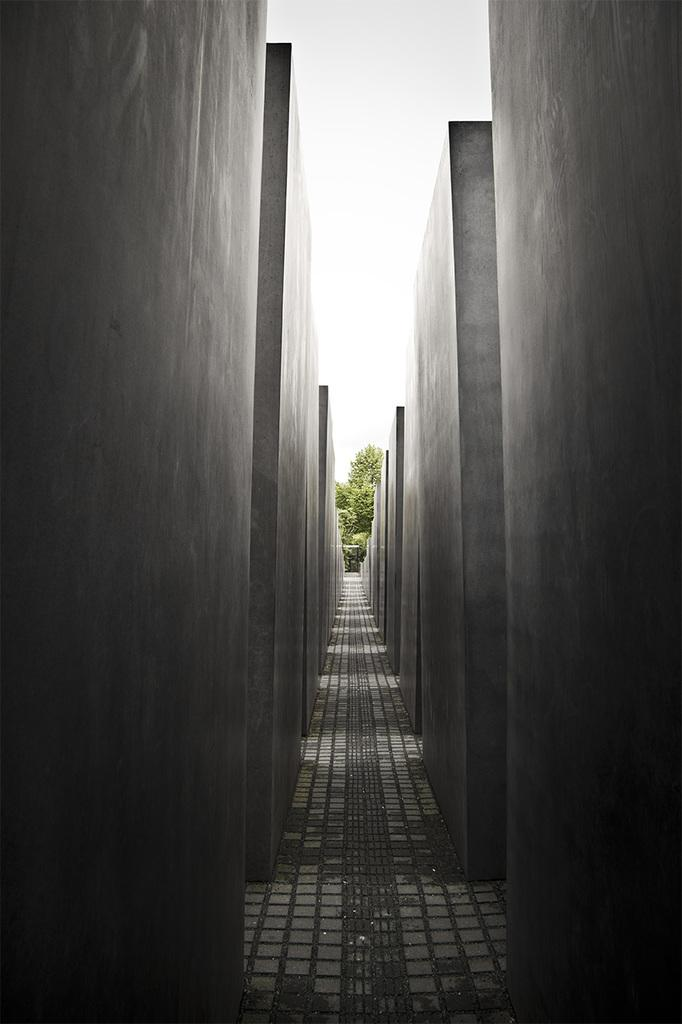What is present on both sides of the image? There are walls on both sides of the image. What is at the bottom of the image? There is pavement at the bottom of the image. What can be seen in the background of the image? There is sky and trees visible in the background of the image. Can you see any celery growing in the image? There is no celery present in the image. How many legs are visible in the image? There are no legs visible in the image. 